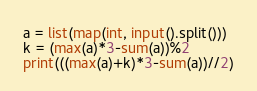Convert code to text. <code><loc_0><loc_0><loc_500><loc_500><_Python_>a = list(map(int, input().split()))
k = (max(a)*3-sum(a))%2
print(((max(a)+k)*3-sum(a))//2)
</code> 